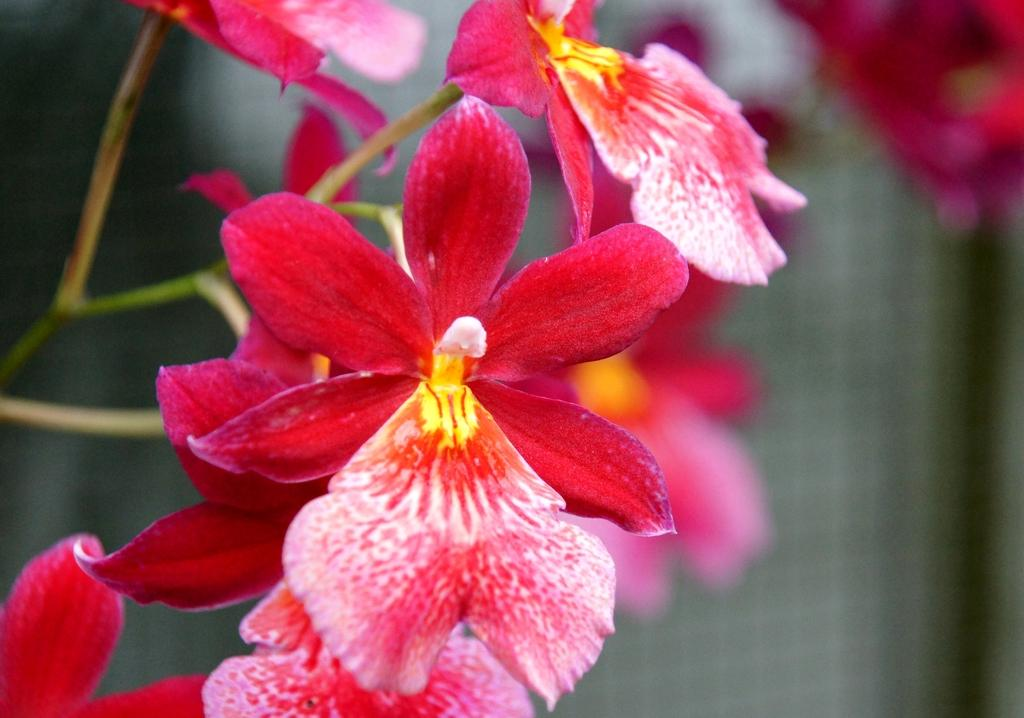What is the main subject of the image? There is a plant in the image. Can you describe the plant in more detail? The plant has many flowers. What can be observed about the background of the image? The background of the image is blurred. What type of cabbage is being harvested by the writer in the image? There is no writer or cabbage present in the image; it features a plant with many flowers. Can you describe the waves in the background of the image? There are no waves present in the image; the background is blurred. 